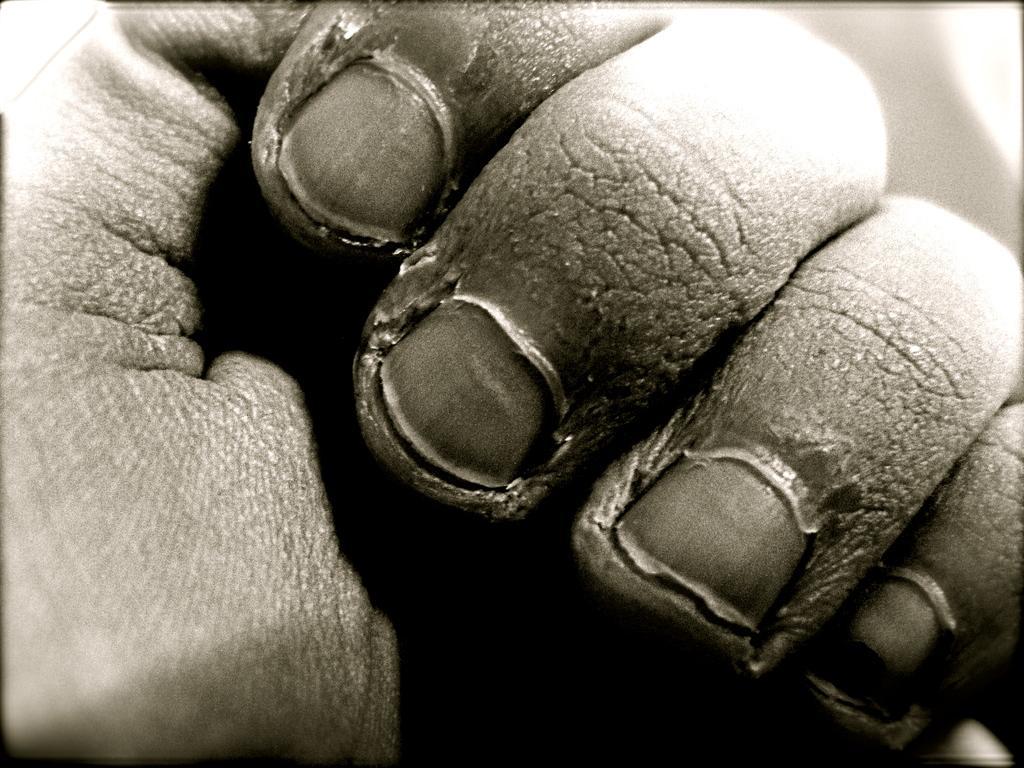Describe this image in one or two sentences. In this image there is one person's hand is visible. 